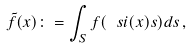<formula> <loc_0><loc_0><loc_500><loc_500>\tilde { f } ( x ) \colon = \int _ { S } f ( \ s i ( x ) s ) d s \, ,</formula> 